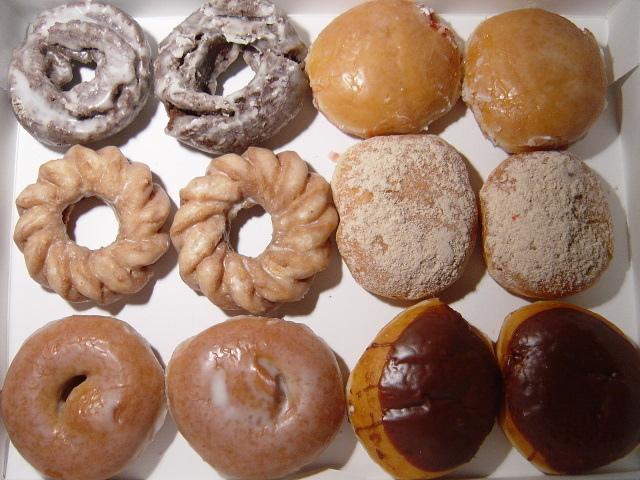Are all these donuts the same?
Give a very brief answer. No. How many doughnuts have chocolate frosting?
Give a very brief answer. 2. When was the picture taken of the donuts?
Short answer required. Today. How many varieties of donuts are there?
Quick response, please. 6. 